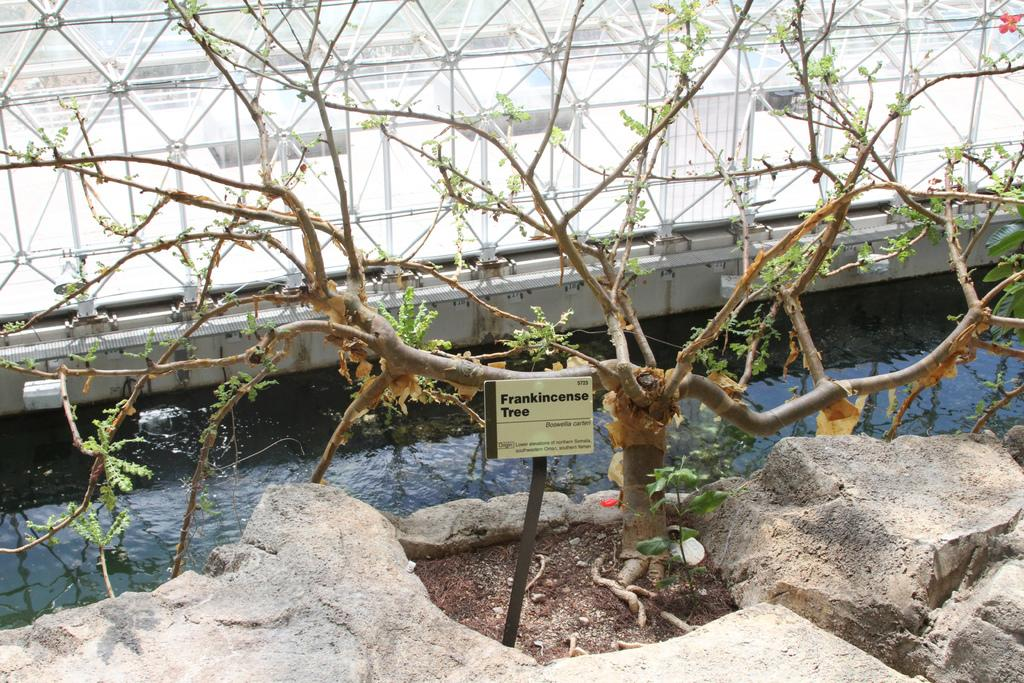What type of plant can be seen in the image? There is a tree in the image. What other natural element is visible in the image? There is a rock visible in the image. What is the third natural element in the image? There is water in the image. What man-made object can be seen in the image? There is a nameplate on a stand in the image. How many toes can be seen on the tree in the image? Trees do not have toes, so none can be seen on the tree in the image. What type of wing is visible on the rock in the image? Rocks do not have wings, so none can be seen on the rock in the image. 